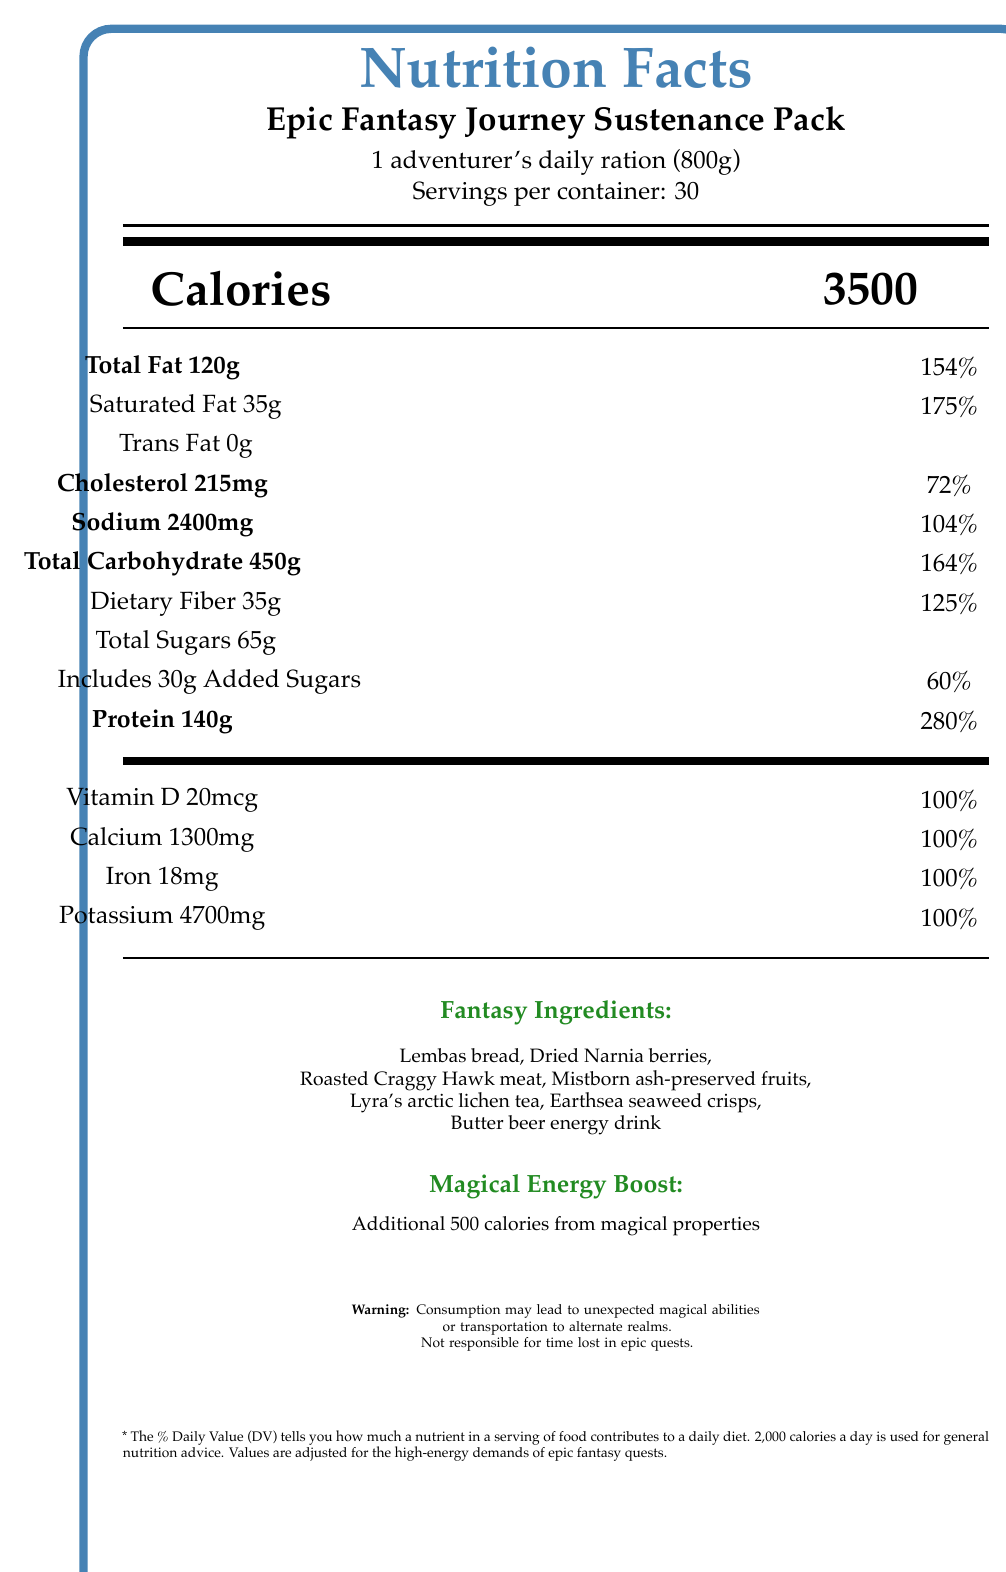what is the total fat content per serving? The document states that the total fat content per serving is 120 grams.
Answer: 120 grams how many servings are there per container? The document lists "Servings per container: 30".
Answer: 30 what is the calorie count for one serving of the sustenance pack? The document states that the calorie count per serving is 3500 calories.
Answer: 3500 calories what is the daily value percentage of protein? The document indicates that the daily value percentage of protein is 280%.
Answer: 280% which fantasy ingredient is inspired by J.R.R. Tolkien's 'The Lord of the Rings'? The document lists Lembas bread as inspired by J.R.R. Tolkien's 'The Lord of the Rings'.
Answer: Lembas bread what percentage of the daily value of dietary fiber does one serving provide? A. 100% B. 110% C. 125% D. 175% The document states that one serving provides 125% of the daily value of dietary fiber.
Answer: C. 125% how many additional calories does the magical enhancement provide? The "Magical Energy Boost" section of the document states an additional 500 calories from magical properties.
Answer: 500 calories which of the following is not listed as a fantasy ingredient? I. Lembas bread II. Dragonfruit III. Earthsea seaweed crisps IV. Lyra's arctic lichen tea Dragonfruit is not listed among the fantasy ingredients in the document.
Answer: II. Dragonfruit does the product contain any trans fat? The document shows that the trans fat content is 0 grams.
Answer: No which item from the document comes from 'The Wheel of Time' series? The document specifies that the Roasted Craggy Hawk meat is inspired by Robert Jordan's 'The Wheel of Time' series.
Answer: Roasted Craggy Hawk meat summarize the nutrition facts of the "Epic Fantasy Journey Sustenance Pack". The document provides detailed information on the nutritional content of the Epic Fantasy Journey Sustenance Pack, highlighting its high caloric density, significant contributions to daily nutrient requirements, and the inclusion of various fantasy-inspired ingredients. It also mentions potential magical side effects.
Answer: The Epic Fantasy Journey Sustenance Pack provides a high-energy, nutrient-dense daily ration designed for adventurers. It includes 3500 calories per serving with a well-rounded array of macronutrients and essential vitamins and minerals. The pack contains fantasy-inspired ingredients and offers additional magical energy boosts while cautioning unexpected magical effects. what is the total weight of one serving? The document notes that one adventurer's daily ration is 800 grams.
Answer: 800 grams what is the product name? The document mentions "Epic Fantasy Journey Sustenance Pack" as the product name.
Answer: Epic Fantasy Journey Sustenance Pack how much cholesterol is there in one serving, and what is the percentage of daily value? The document states that there are 215mg of cholesterol per serving, which accounts for 72% of the daily value.
Answer: 215mg, 72% is there enough information to determine if the product is gluten-free? The document does not provide any information regarding whether the product is gluten-free.
Answer: Not enough information 